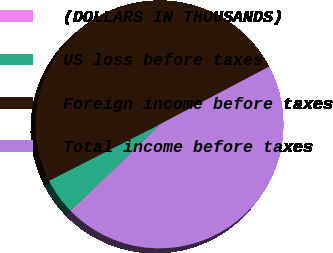Convert chart. <chart><loc_0><loc_0><loc_500><loc_500><pie_chart><fcel>(DOLLARS IN THOUSANDS)<fcel>US loss before taxes<fcel>Foreign income before taxes<fcel>Total income before taxes<nl><fcel>0.24%<fcel>4.81%<fcel>49.76%<fcel>45.19%<nl></chart> 